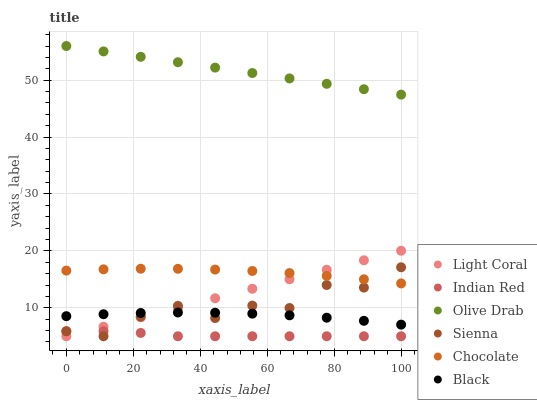Does Indian Red have the minimum area under the curve?
Answer yes or no. Yes. Does Olive Drab have the maximum area under the curve?
Answer yes or no. Yes. Does Chocolate have the minimum area under the curve?
Answer yes or no. No. Does Chocolate have the maximum area under the curve?
Answer yes or no. No. Is Light Coral the smoothest?
Answer yes or no. Yes. Is Sienna the roughest?
Answer yes or no. Yes. Is Chocolate the smoothest?
Answer yes or no. No. Is Chocolate the roughest?
Answer yes or no. No. Does Sienna have the lowest value?
Answer yes or no. Yes. Does Chocolate have the lowest value?
Answer yes or no. No. Does Olive Drab have the highest value?
Answer yes or no. Yes. Does Chocolate have the highest value?
Answer yes or no. No. Is Black less than Olive Drab?
Answer yes or no. Yes. Is Chocolate greater than Indian Red?
Answer yes or no. Yes. Does Black intersect Light Coral?
Answer yes or no. Yes. Is Black less than Light Coral?
Answer yes or no. No. Is Black greater than Light Coral?
Answer yes or no. No. Does Black intersect Olive Drab?
Answer yes or no. No. 